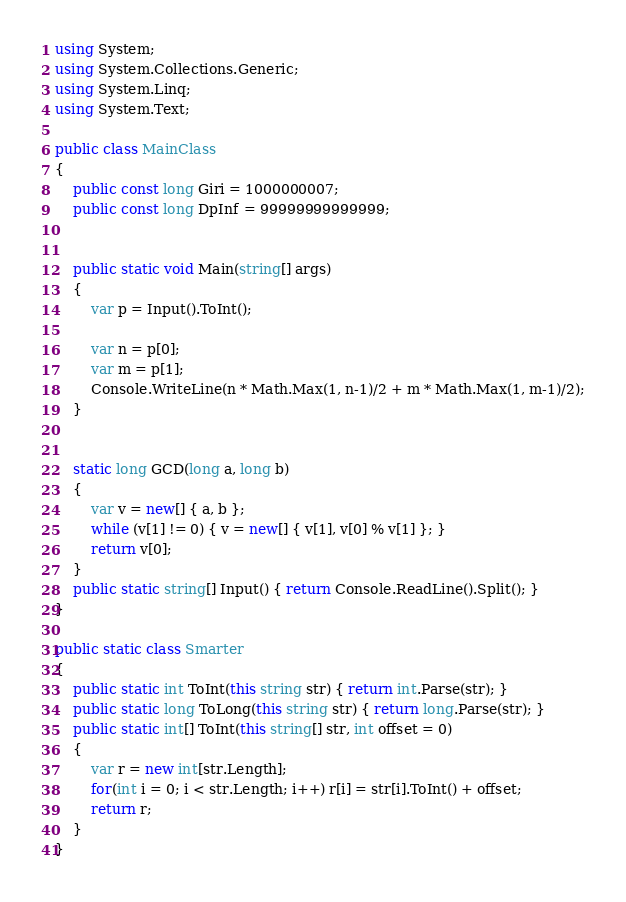Convert code to text. <code><loc_0><loc_0><loc_500><loc_500><_C#_>using System;
using System.Collections.Generic;
using System.Linq;
using System.Text;

public class MainClass
{
	public const long Giri = 1000000007;
	public const long DpInf = 99999999999999;
	
	
	public static void Main(string[] args)
	{
 		var p = Input().ToInt();
 		
 		var n = p[0];
 		var m = p[1];
 		Console.WriteLine(n * Math.Max(1, n-1)/2 + m * Math.Max(1, m-1)/2);
	}
	
	
	static long GCD(long a, long b)
	{
		var v = new[] { a, b };
		while (v[1] != 0) { v = new[] { v[1], v[0] % v[1] }; }
		return v[0];
	}
	public static string[] Input() { return Console.ReadLine().Split(); }
}

public static class Smarter
{
	public static int ToInt(this string str) { return int.Parse(str); }
	public static long ToLong(this string str) { return long.Parse(str); }
	public static int[] ToInt(this string[] str, int offset = 0)
	{
		var r = new int[str.Length];
		for(int i = 0; i < str.Length; i++) r[i] = str[i].ToInt() + offset;
		return r;
	}
}</code> 